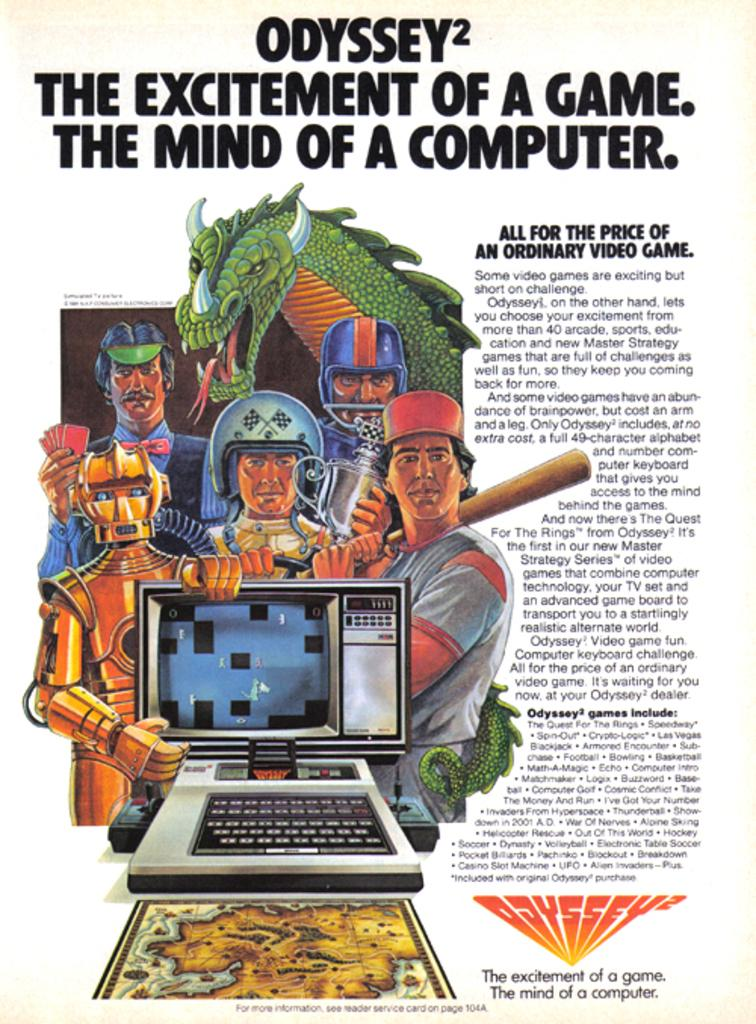<image>
Write a terse but informative summary of the picture. Poster showing a group of people as well as a dragon and robot and says "Odyssey 2" on top. 